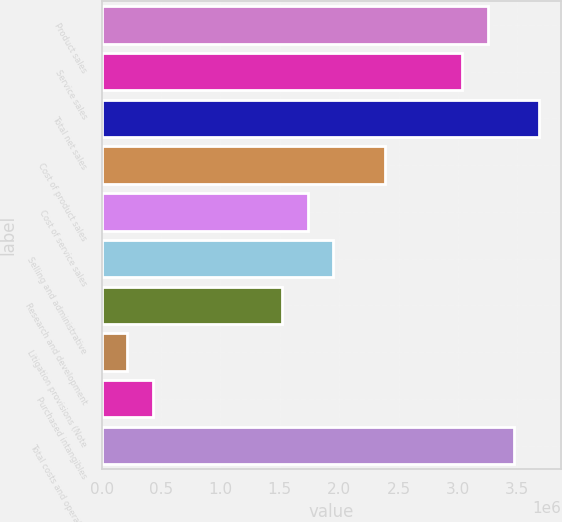<chart> <loc_0><loc_0><loc_500><loc_500><bar_chart><fcel>Product sales<fcel>Service sales<fcel>Total net sales<fcel>Cost of product sales<fcel>Cost of service sales<fcel>Selling and administrative<fcel>Research and development<fcel>Litigation provisions (Note<fcel>Purchased intangibles<fcel>Total costs and operating<nl><fcel>3.25113e+06<fcel>3.03439e+06<fcel>3.68461e+06<fcel>2.38416e+06<fcel>1.73394e+06<fcel>1.95068e+06<fcel>1.5172e+06<fcel>216748<fcel>433490<fcel>3.46787e+06<nl></chart> 